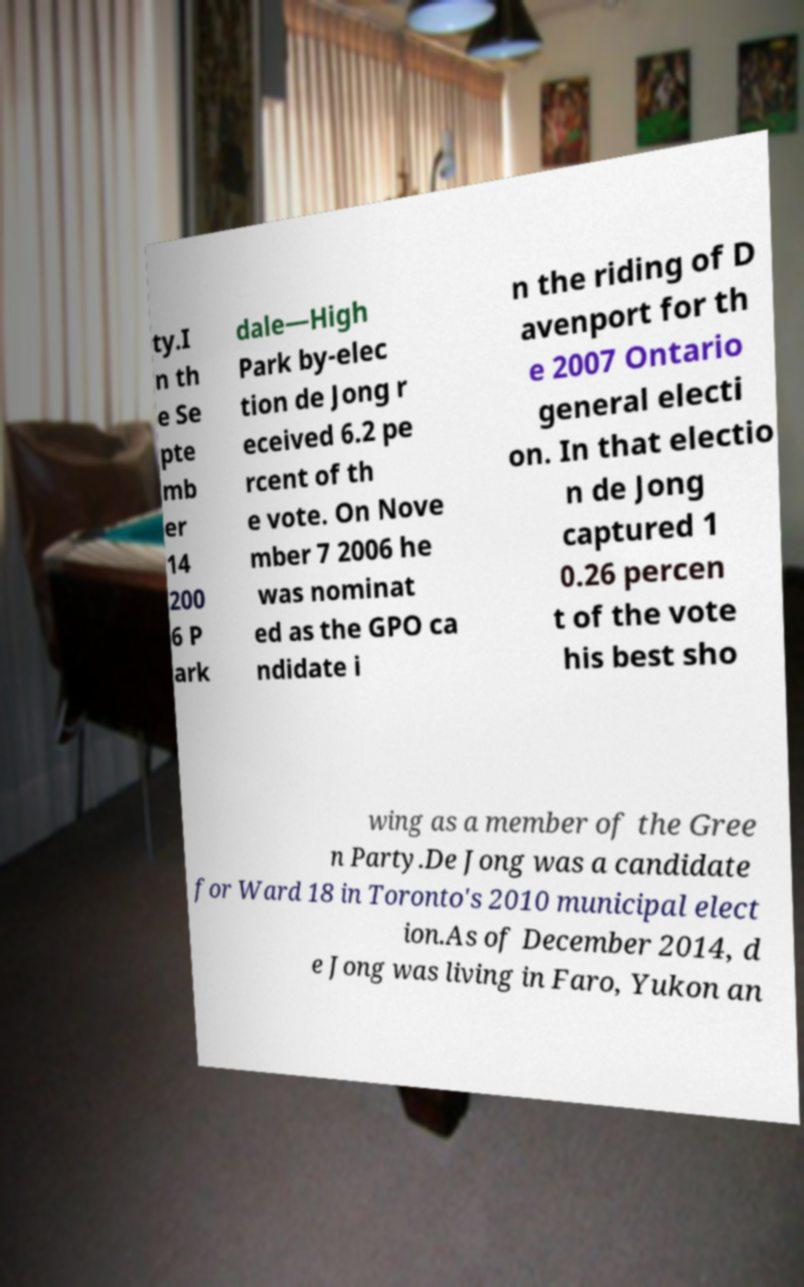Please read and relay the text visible in this image. What does it say? ty.I n th e Se pte mb er 14 200 6 P ark dale—High Park by-elec tion de Jong r eceived 6.2 pe rcent of th e vote. On Nove mber 7 2006 he was nominat ed as the GPO ca ndidate i n the riding of D avenport for th e 2007 Ontario general electi on. In that electio n de Jong captured 1 0.26 percen t of the vote his best sho wing as a member of the Gree n Party.De Jong was a candidate for Ward 18 in Toronto's 2010 municipal elect ion.As of December 2014, d e Jong was living in Faro, Yukon an 